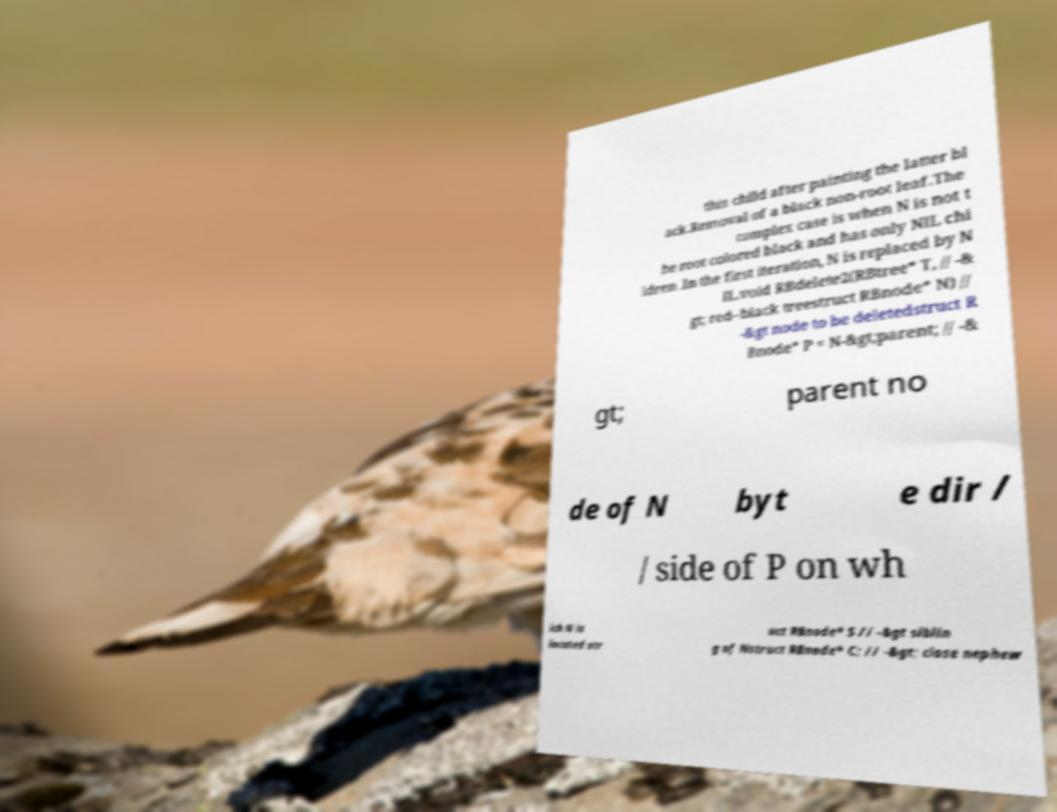There's text embedded in this image that I need extracted. Can you transcribe it verbatim? this child after painting the latter bl ack.Removal of a black non-root leaf.The complex case is when N is not t he root colored black and has only NIL chi ldren .In the first iteration, N is replaced by N IL.void RBdelete2(RBtree* T, // -& gt; red–black treestruct RBnode* N) // -&gt node to be deletedstruct R Bnode* P = N-&gt;parent; // -& gt; parent no de of N byt e dir / / side of P on wh ich N is located str uct RBnode* S // -&gt siblin g of Nstruct RBnode* C; // -&gt; close nephew 